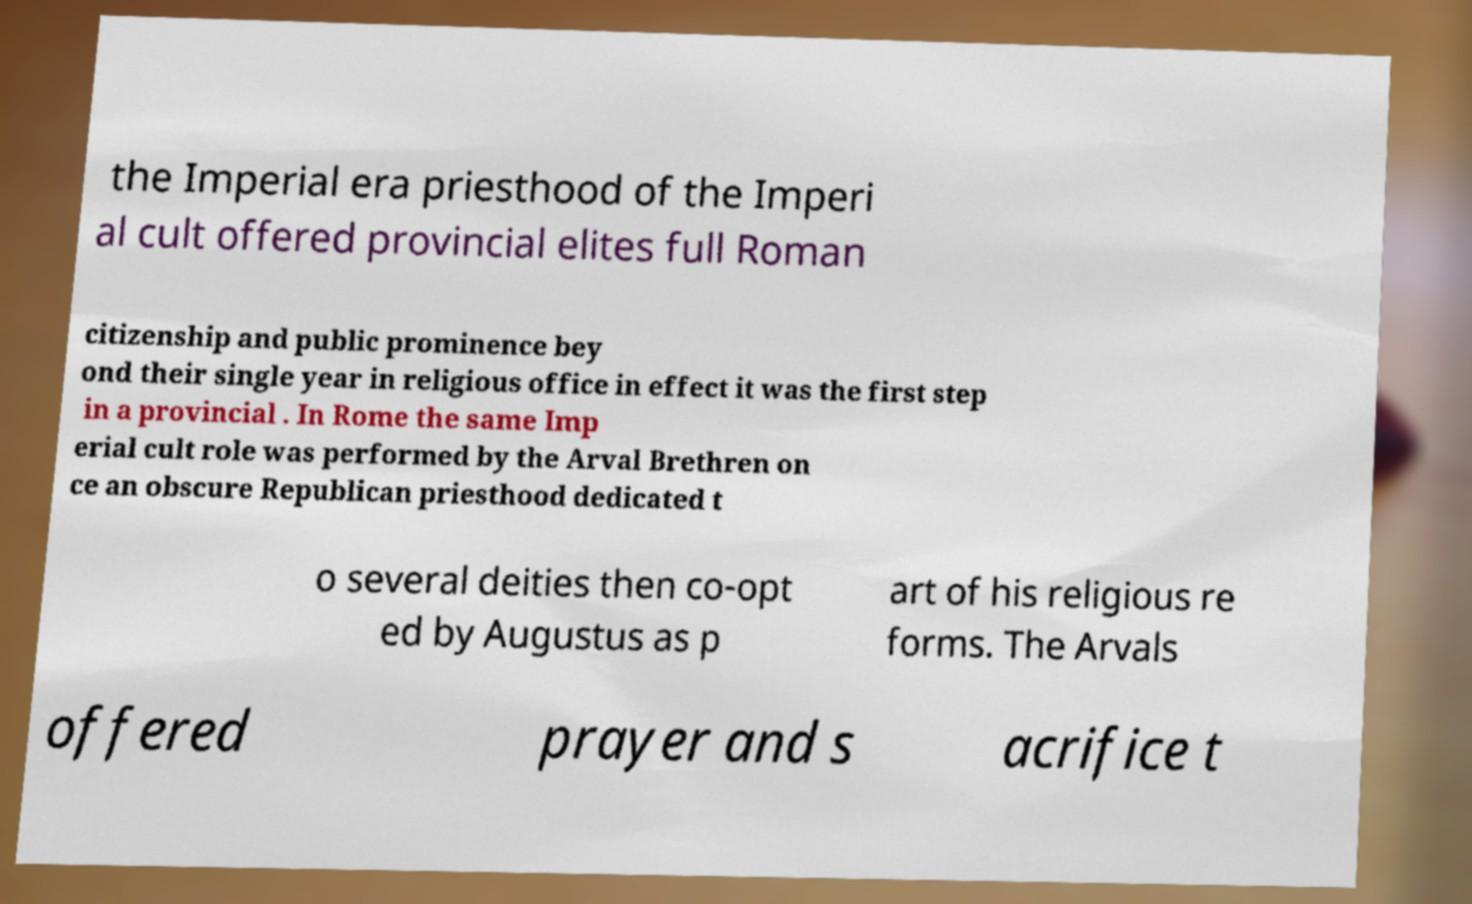Can you read and provide the text displayed in the image?This photo seems to have some interesting text. Can you extract and type it out for me? the Imperial era priesthood of the Imperi al cult offered provincial elites full Roman citizenship and public prominence bey ond their single year in religious office in effect it was the first step in a provincial . In Rome the same Imp erial cult role was performed by the Arval Brethren on ce an obscure Republican priesthood dedicated t o several deities then co-opt ed by Augustus as p art of his religious re forms. The Arvals offered prayer and s acrifice t 